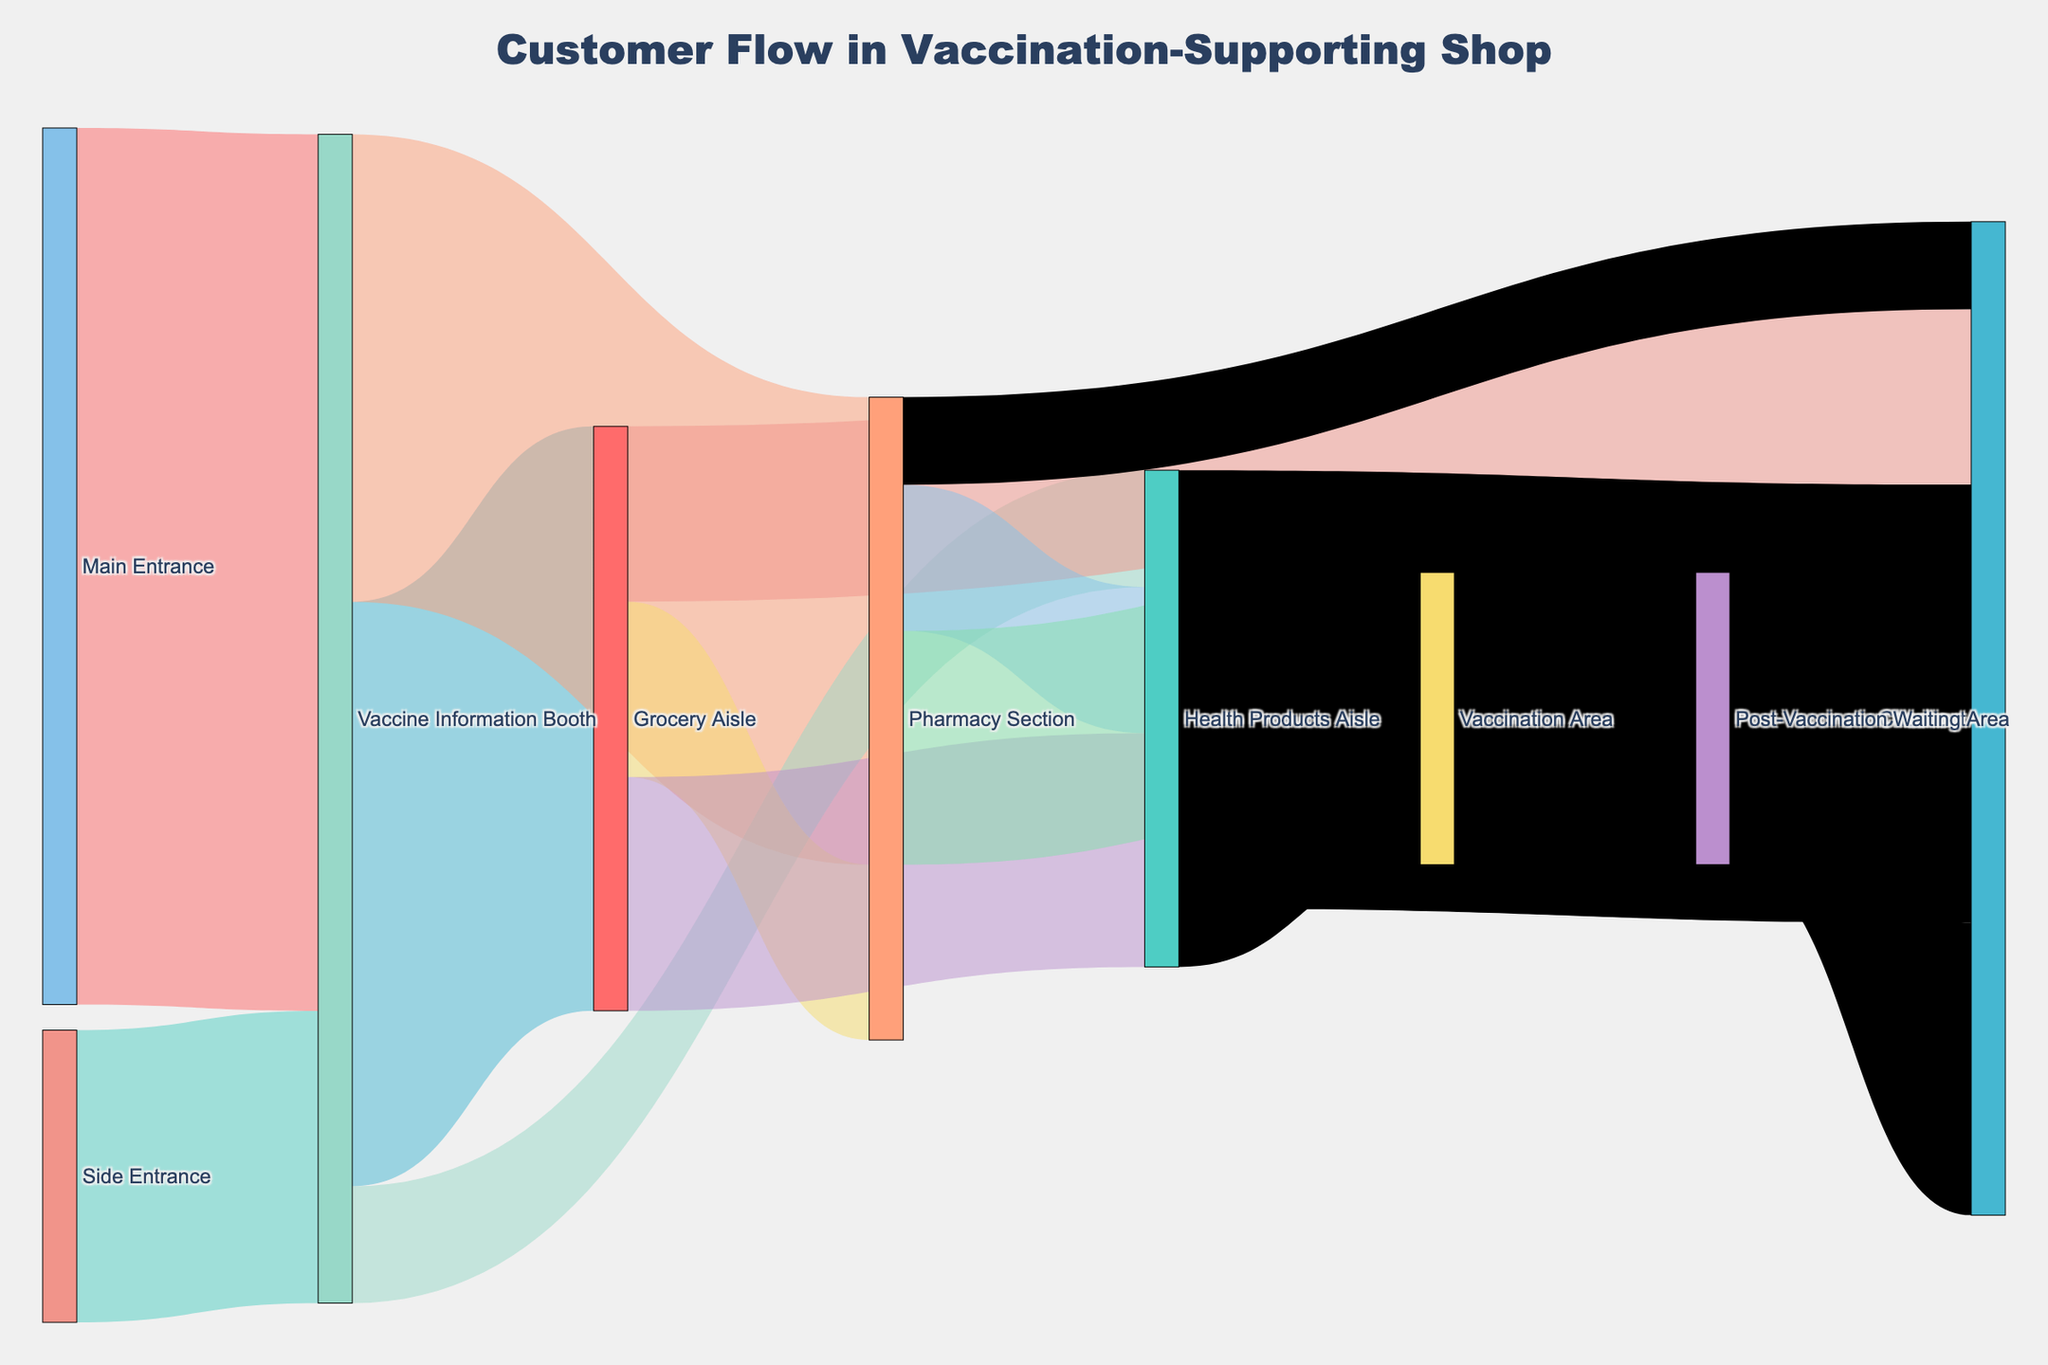What's the title of the Sankey Diagram? The title of the diagram is typically placed at the top and provides a summary of what the diagram represents.
Answer: Customer Flow in Vaccination-Supporting Shop How many customers entered through the Main Entrance? Check the flow from the Main Entrance and sum the values leading to various sections.
Answer: 150 What is the total number of customers who visited the Vaccine Information Booth? To find this, sum the values of all flows entering the Vaccine Information Booth.
Answer: 200 Which aisle has the highest number of customers flowing into the Vaccination Area? Compare the values of flows into the Vaccination Area from the different aisles.
Answer: Pharmacy Section How many more customers went to the Grocery Aisle compared to the Pharmacy Section from the Vaccine Information Booth? Subtract the number of customers going to the Pharmacy Section from those going to the Grocery Aisle.
Answer: 20 What is the total number of customers who eventually end up at the checkout? Sum all the values of flows leading directly to the Checkout from different sections.
Answer: 170 Compare the number of customers flowing into the Health Products Aisle from the Grocery Aisle and the Pharmacy Section. Look at the values of flows from the Grocery Aisle and the Pharmacy Section to the Health Products Aisle and compare them.
Answer: 40 from Grocery Aisle and 25 from Pharmacy Section How many customers visited the Post-Vaccination Waiting Area? The number of customers in the Post-Vaccination Waiting Area is represented by the value of the flow coming from the Vaccination Area.
Answer: 50 What is the combined total of customers entering through both the Main and Side Entrances? Add the values of customers entering from the Main Entrance and the Side Entrance.
Answer: 200 What is the final destination for the majority of customers? Look at all the flows and determine which destination has the highest total value of incoming flows.
Answer: Checkout 